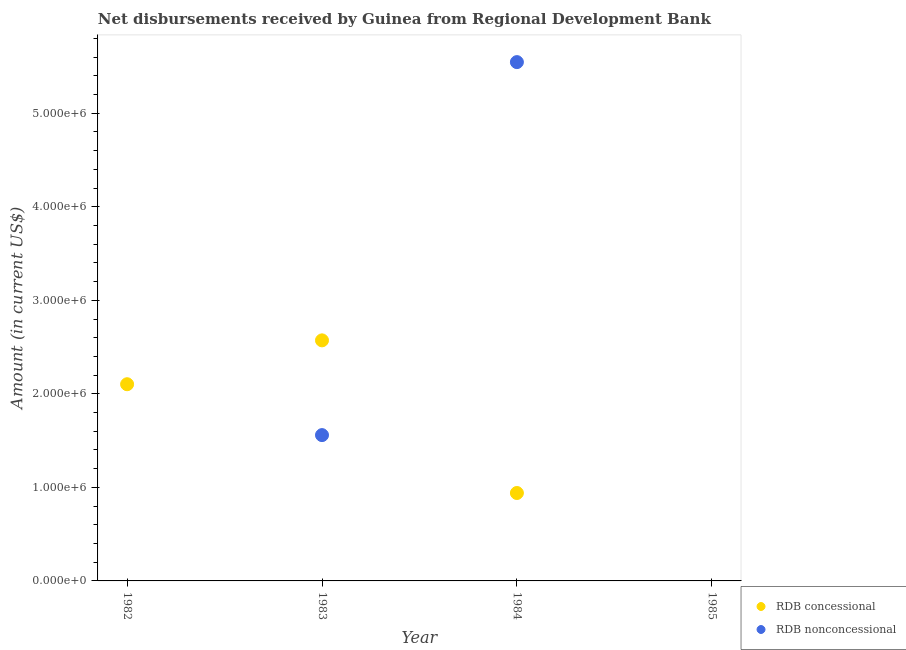What is the net concessional disbursements from rdb in 1983?
Your response must be concise. 2.57e+06. Across all years, what is the maximum net concessional disbursements from rdb?
Offer a very short reply. 2.57e+06. Across all years, what is the minimum net concessional disbursements from rdb?
Provide a succinct answer. 0. What is the total net non concessional disbursements from rdb in the graph?
Your answer should be very brief. 7.11e+06. What is the difference between the net concessional disbursements from rdb in 1982 and that in 1983?
Offer a terse response. -4.69e+05. What is the difference between the net non concessional disbursements from rdb in 1985 and the net concessional disbursements from rdb in 1983?
Your answer should be compact. -2.57e+06. What is the average net concessional disbursements from rdb per year?
Provide a short and direct response. 1.40e+06. In the year 1983, what is the difference between the net non concessional disbursements from rdb and net concessional disbursements from rdb?
Your response must be concise. -1.01e+06. What is the ratio of the net concessional disbursements from rdb in 1982 to that in 1984?
Keep it short and to the point. 2.24. What is the difference between the highest and the second highest net concessional disbursements from rdb?
Make the answer very short. 4.69e+05. What is the difference between the highest and the lowest net non concessional disbursements from rdb?
Give a very brief answer. 5.55e+06. What is the difference between two consecutive major ticks on the Y-axis?
Offer a terse response. 1.00e+06. Does the graph contain grids?
Offer a terse response. No. Where does the legend appear in the graph?
Keep it short and to the point. Bottom right. What is the title of the graph?
Provide a succinct answer. Net disbursements received by Guinea from Regional Development Bank. Does "From human activities" appear as one of the legend labels in the graph?
Provide a short and direct response. No. What is the label or title of the X-axis?
Give a very brief answer. Year. What is the label or title of the Y-axis?
Your response must be concise. Amount (in current US$). What is the Amount (in current US$) in RDB concessional in 1982?
Your answer should be very brief. 2.10e+06. What is the Amount (in current US$) of RDB nonconcessional in 1982?
Offer a terse response. 0. What is the Amount (in current US$) of RDB concessional in 1983?
Make the answer very short. 2.57e+06. What is the Amount (in current US$) of RDB nonconcessional in 1983?
Your answer should be compact. 1.56e+06. What is the Amount (in current US$) of RDB concessional in 1984?
Provide a succinct answer. 9.40e+05. What is the Amount (in current US$) of RDB nonconcessional in 1984?
Ensure brevity in your answer.  5.55e+06. What is the Amount (in current US$) in RDB concessional in 1985?
Keep it short and to the point. 0. Across all years, what is the maximum Amount (in current US$) in RDB concessional?
Provide a succinct answer. 2.57e+06. Across all years, what is the maximum Amount (in current US$) in RDB nonconcessional?
Give a very brief answer. 5.55e+06. Across all years, what is the minimum Amount (in current US$) in RDB concessional?
Provide a succinct answer. 0. What is the total Amount (in current US$) in RDB concessional in the graph?
Keep it short and to the point. 5.62e+06. What is the total Amount (in current US$) in RDB nonconcessional in the graph?
Keep it short and to the point. 7.11e+06. What is the difference between the Amount (in current US$) in RDB concessional in 1982 and that in 1983?
Your response must be concise. -4.69e+05. What is the difference between the Amount (in current US$) in RDB concessional in 1982 and that in 1984?
Ensure brevity in your answer.  1.16e+06. What is the difference between the Amount (in current US$) of RDB concessional in 1983 and that in 1984?
Give a very brief answer. 1.63e+06. What is the difference between the Amount (in current US$) of RDB nonconcessional in 1983 and that in 1984?
Keep it short and to the point. -3.99e+06. What is the difference between the Amount (in current US$) of RDB concessional in 1982 and the Amount (in current US$) of RDB nonconcessional in 1983?
Offer a terse response. 5.44e+05. What is the difference between the Amount (in current US$) in RDB concessional in 1982 and the Amount (in current US$) in RDB nonconcessional in 1984?
Give a very brief answer. -3.44e+06. What is the difference between the Amount (in current US$) in RDB concessional in 1983 and the Amount (in current US$) in RDB nonconcessional in 1984?
Provide a short and direct response. -2.98e+06. What is the average Amount (in current US$) in RDB concessional per year?
Provide a short and direct response. 1.40e+06. What is the average Amount (in current US$) in RDB nonconcessional per year?
Ensure brevity in your answer.  1.78e+06. In the year 1983, what is the difference between the Amount (in current US$) in RDB concessional and Amount (in current US$) in RDB nonconcessional?
Provide a short and direct response. 1.01e+06. In the year 1984, what is the difference between the Amount (in current US$) of RDB concessional and Amount (in current US$) of RDB nonconcessional?
Keep it short and to the point. -4.61e+06. What is the ratio of the Amount (in current US$) in RDB concessional in 1982 to that in 1983?
Your response must be concise. 0.82. What is the ratio of the Amount (in current US$) in RDB concessional in 1982 to that in 1984?
Offer a terse response. 2.24. What is the ratio of the Amount (in current US$) in RDB concessional in 1983 to that in 1984?
Your response must be concise. 2.74. What is the ratio of the Amount (in current US$) in RDB nonconcessional in 1983 to that in 1984?
Offer a terse response. 0.28. What is the difference between the highest and the second highest Amount (in current US$) in RDB concessional?
Keep it short and to the point. 4.69e+05. What is the difference between the highest and the lowest Amount (in current US$) in RDB concessional?
Your answer should be very brief. 2.57e+06. What is the difference between the highest and the lowest Amount (in current US$) in RDB nonconcessional?
Offer a very short reply. 5.55e+06. 